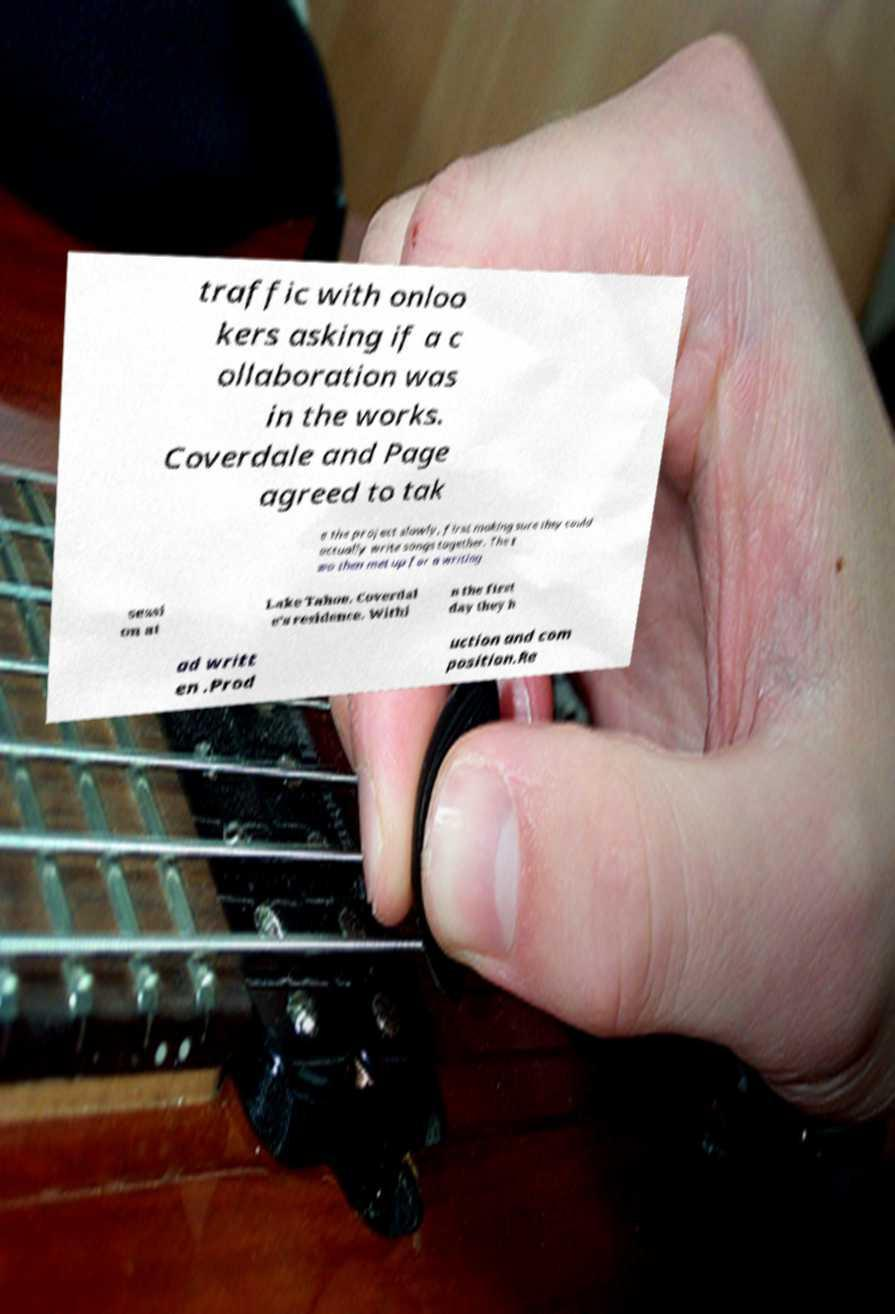Can you accurately transcribe the text from the provided image for me? traffic with onloo kers asking if a c ollaboration was in the works. Coverdale and Page agreed to tak e the project slowly, first making sure they could actually write songs together. The t wo then met up for a writing sessi on at Lake Tahoe, Coverdal e's residence. Withi n the first day they h ad writt en .Prod uction and com position.Re 